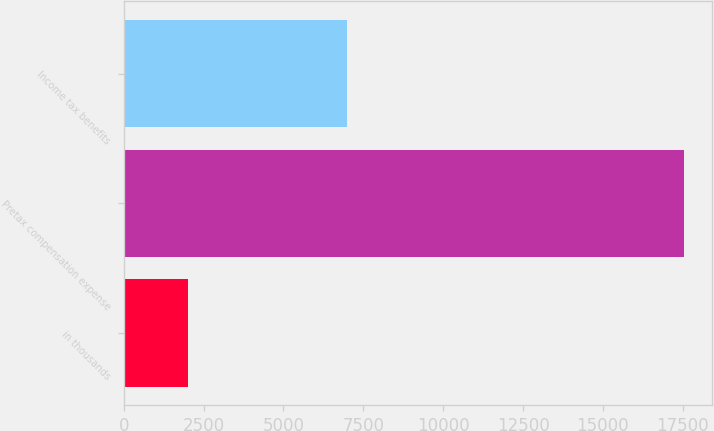Convert chart to OTSL. <chart><loc_0><loc_0><loc_500><loc_500><bar_chart><fcel>in thousands<fcel>Pretax compensation expense<fcel>Income tax benefits<nl><fcel>2011<fcel>17537<fcel>6976<nl></chart> 